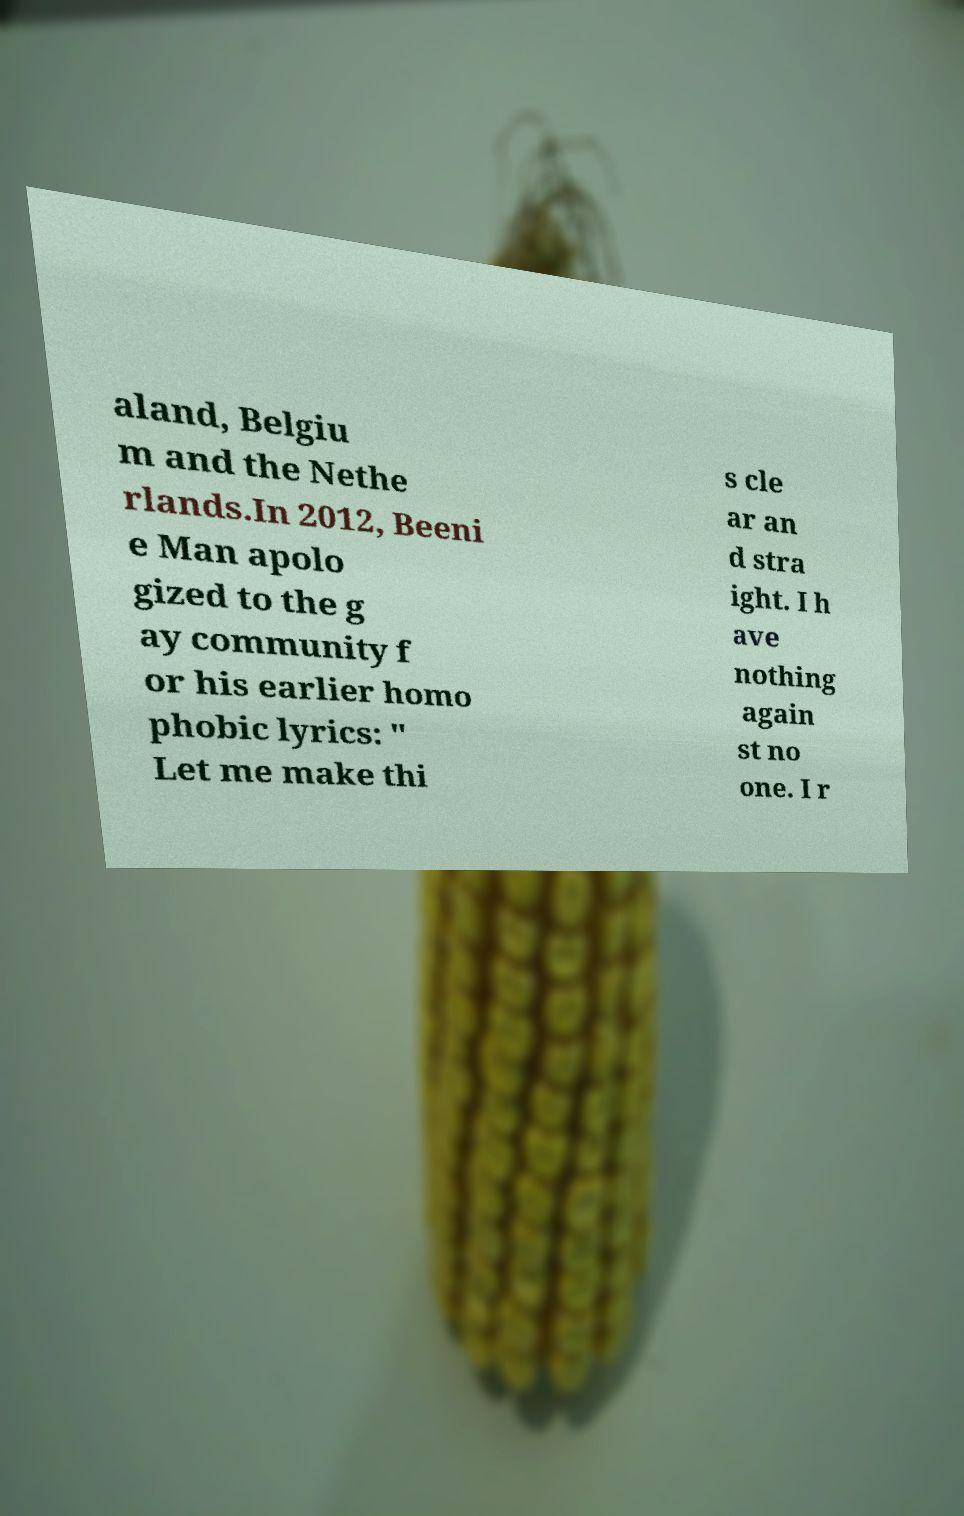I need the written content from this picture converted into text. Can you do that? aland, Belgiu m and the Nethe rlands.In 2012, Beeni e Man apolo gized to the g ay community f or his earlier homo phobic lyrics: " Let me make thi s cle ar an d stra ight. I h ave nothing again st no one. I r 